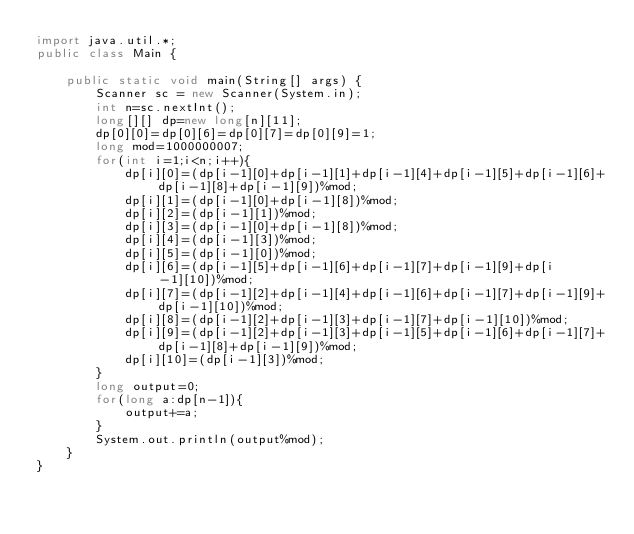<code> <loc_0><loc_0><loc_500><loc_500><_Java_>import java.util.*;
public class Main {

    public static void main(String[] args) {
        Scanner sc = new Scanner(System.in);
        int n=sc.nextInt();
        long[][] dp=new long[n][11];
        dp[0][0]=dp[0][6]=dp[0][7]=dp[0][9]=1;
        long mod=1000000007;
        for(int i=1;i<n;i++){
            dp[i][0]=(dp[i-1][0]+dp[i-1][1]+dp[i-1][4]+dp[i-1][5]+dp[i-1][6]+dp[i-1][8]+dp[i-1][9])%mod;
            dp[i][1]=(dp[i-1][0]+dp[i-1][8])%mod;
            dp[i][2]=(dp[i-1][1])%mod;
            dp[i][3]=(dp[i-1][0]+dp[i-1][8])%mod;
            dp[i][4]=(dp[i-1][3])%mod;
            dp[i][5]=(dp[i-1][0])%mod;
            dp[i][6]=(dp[i-1][5]+dp[i-1][6]+dp[i-1][7]+dp[i-1][9]+dp[i-1][10])%mod;
            dp[i][7]=(dp[i-1][2]+dp[i-1][4]+dp[i-1][6]+dp[i-1][7]+dp[i-1][9]+dp[i-1][10])%mod;
            dp[i][8]=(dp[i-1][2]+dp[i-1][3]+dp[i-1][7]+dp[i-1][10])%mod;
            dp[i][9]=(dp[i-1][2]+dp[i-1][3]+dp[i-1][5]+dp[i-1][6]+dp[i-1][7]+dp[i-1][8]+dp[i-1][9])%mod;
            dp[i][10]=(dp[i-1][3])%mod;
        }
        long output=0;
        for(long a:dp[n-1]){
            output+=a;
        }
        System.out.println(output%mod);
    }
}</code> 